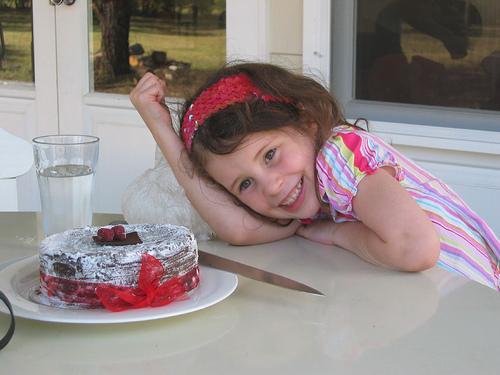Where is the knife?
Concise answer only. On plate. How many people are in the family picture?
Be succinct. 1. Is this person a baker or just a customer?
Be succinct. Customer. What is the cake made of??
Be succinct. Chocolate. What kind of dessert is in the photo?
Keep it brief. Cake. Is this a girl or boy?
Be succinct. Girl. What is on the top of the cake?
Give a very brief answer. Berries. Does the cake appear sturdy?
Give a very brief answer. Yes. What is this girl going to eat?
Short answer required. Cake. Is the knife by the cake a bread knife?
Answer briefly. No. What is the design on the plate?
Answer briefly. Plain. How many glasses are on the cake?
Be succinct. 0. What is the baby eating?
Short answer required. Cake. 